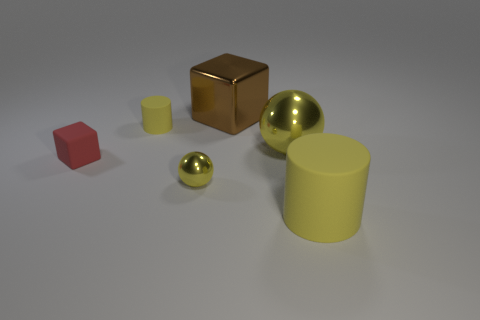What might be the purpose of this arrangement of objects? The objects in the image might be arranged for a visual composition exercise, possibly in a study of forms, layout, and colors in a 3D modeling software or a photography setup. The simple geometric shapes are evenly spaced, which might suggest an educational or demonstrative purpose, such as in a tutorial for understanding spatial relationships and perspective or for a lesson in shading and light reflections in different materials. 